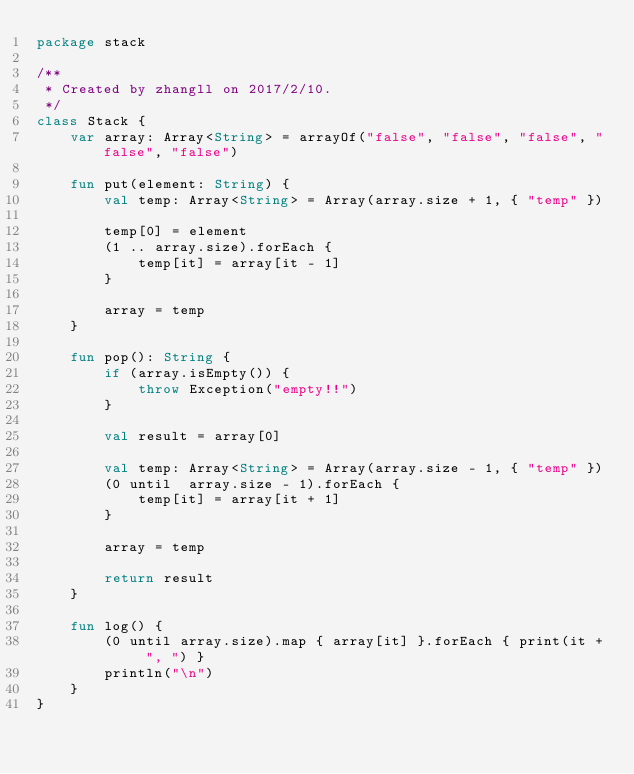Convert code to text. <code><loc_0><loc_0><loc_500><loc_500><_Kotlin_>package stack

/**
 * Created by zhangll on 2017/2/10.
 */
class Stack {
    var array: Array<String> = arrayOf("false", "false", "false", "false", "false")

    fun put(element: String) {
        val temp: Array<String> = Array(array.size + 1, { "temp" })

        temp[0] = element
        (1 .. array.size).forEach {
            temp[it] = array[it - 1]
        }

        array = temp
    }

    fun pop(): String {
        if (array.isEmpty()) {
            throw Exception("empty!!")
        }

        val result = array[0]

        val temp: Array<String> = Array(array.size - 1, { "temp" })
        (0 until  array.size - 1).forEach {
            temp[it] = array[it + 1]
        }

        array = temp

        return result
    }

    fun log() {
        (0 until array.size).map { array[it] }.forEach { print(it + ", ") }
        println("\n")
    }
}</code> 